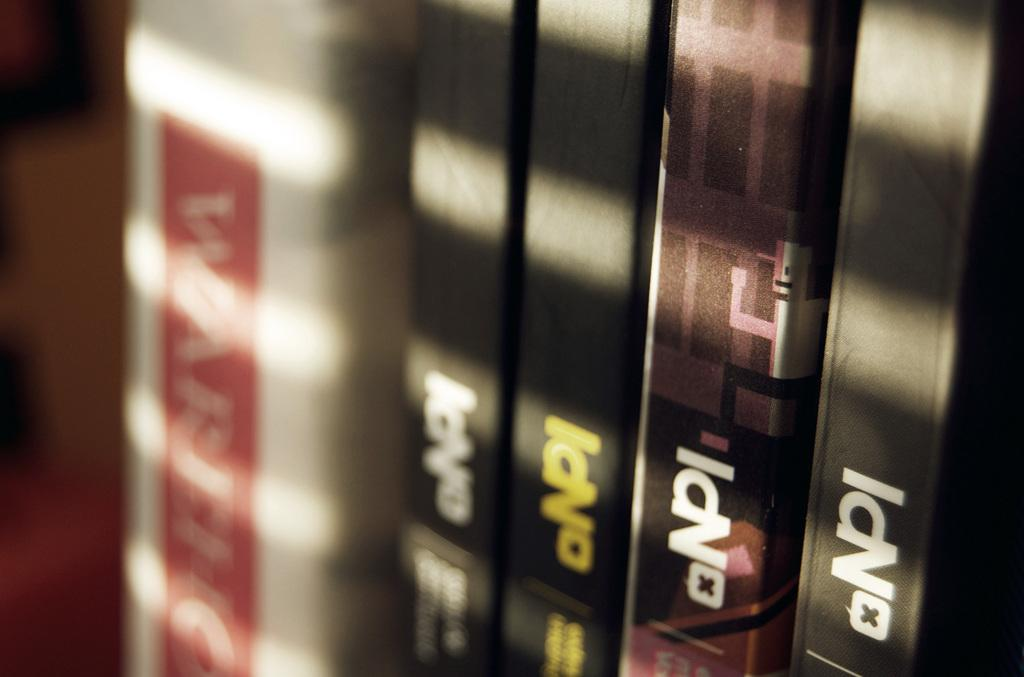Provide a one-sentence caption for the provided image. A row of books that all say NPI. 